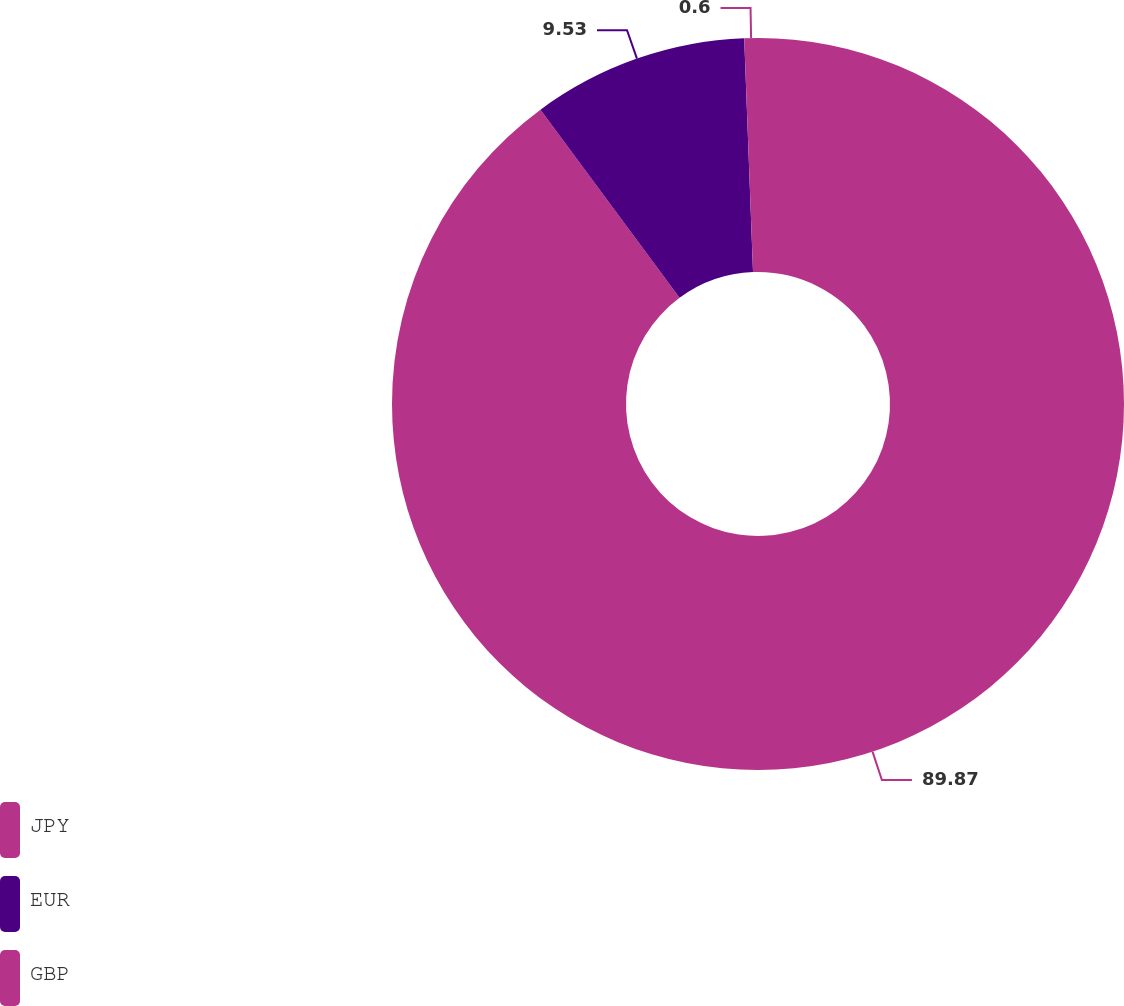Convert chart. <chart><loc_0><loc_0><loc_500><loc_500><pie_chart><fcel>JPY<fcel>EUR<fcel>GBP<nl><fcel>89.87%<fcel>9.53%<fcel>0.6%<nl></chart> 